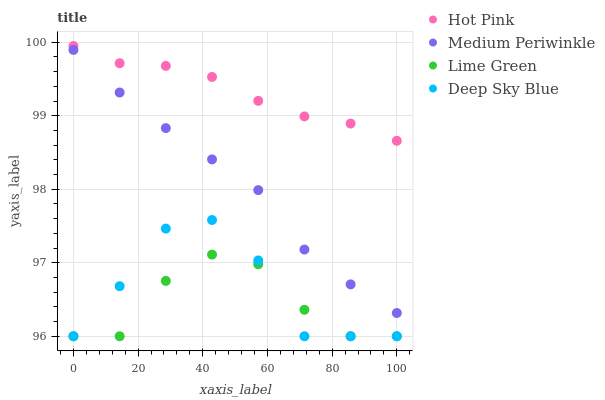Does Lime Green have the minimum area under the curve?
Answer yes or no. Yes. Does Hot Pink have the maximum area under the curve?
Answer yes or no. Yes. Does Medium Periwinkle have the minimum area under the curve?
Answer yes or no. No. Does Medium Periwinkle have the maximum area under the curve?
Answer yes or no. No. Is Hot Pink the smoothest?
Answer yes or no. Yes. Is Deep Sky Blue the roughest?
Answer yes or no. Yes. Is Medium Periwinkle the smoothest?
Answer yes or no. No. Is Medium Periwinkle the roughest?
Answer yes or no. No. Does Lime Green have the lowest value?
Answer yes or no. Yes. Does Medium Periwinkle have the lowest value?
Answer yes or no. No. Does Hot Pink have the highest value?
Answer yes or no. Yes. Does Medium Periwinkle have the highest value?
Answer yes or no. No. Is Deep Sky Blue less than Medium Periwinkle?
Answer yes or no. Yes. Is Hot Pink greater than Deep Sky Blue?
Answer yes or no. Yes. Does Deep Sky Blue intersect Lime Green?
Answer yes or no. Yes. Is Deep Sky Blue less than Lime Green?
Answer yes or no. No. Is Deep Sky Blue greater than Lime Green?
Answer yes or no. No. Does Deep Sky Blue intersect Medium Periwinkle?
Answer yes or no. No. 